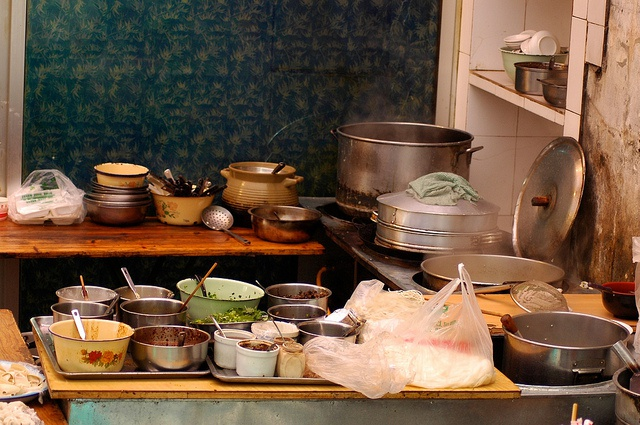Describe the objects in this image and their specific colors. I can see bowl in tan, black, and maroon tones, bowl in tan, orange, and brown tones, oven in tan, black, maroon, and white tones, bowl in tan, maroon, black, and gray tones, and bowl in tan, olive, khaki, and black tones in this image. 